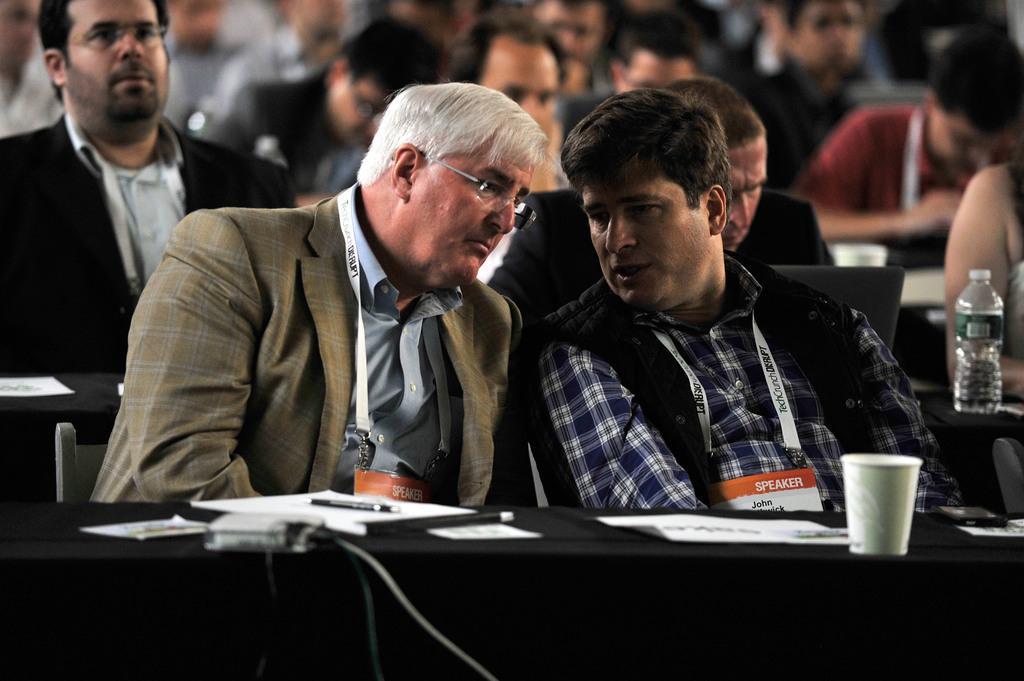Please provide a concise description of this image. In the foreground of this picture, there are two men sitting on the chair in front of a table where we can see pen, paper, glass, paper weight, cables on the table. In the background, there are persons sitting on the chair with laptops on the desk. 